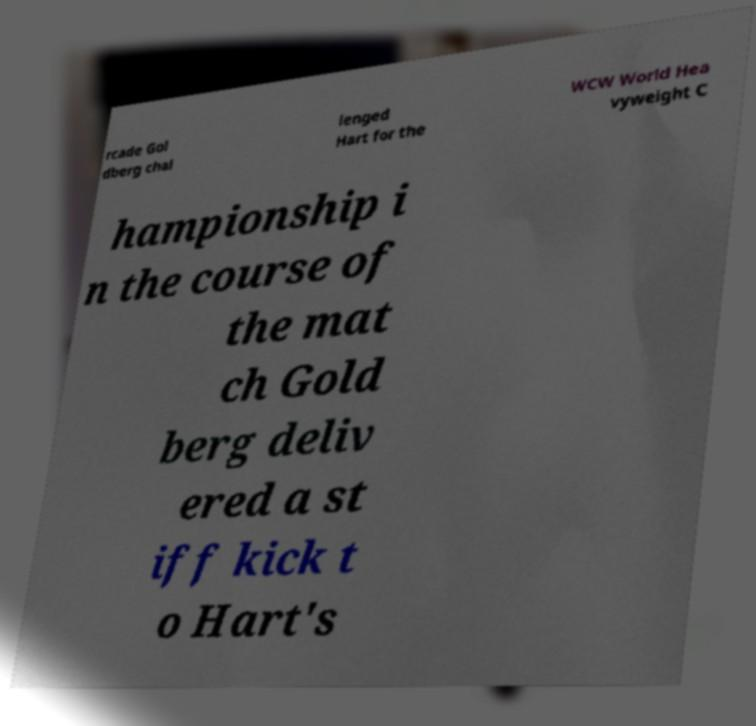Please read and relay the text visible in this image. What does it say? rcade Gol dberg chal lenged Hart for the WCW World Hea vyweight C hampionship i n the course of the mat ch Gold berg deliv ered a st iff kick t o Hart's 